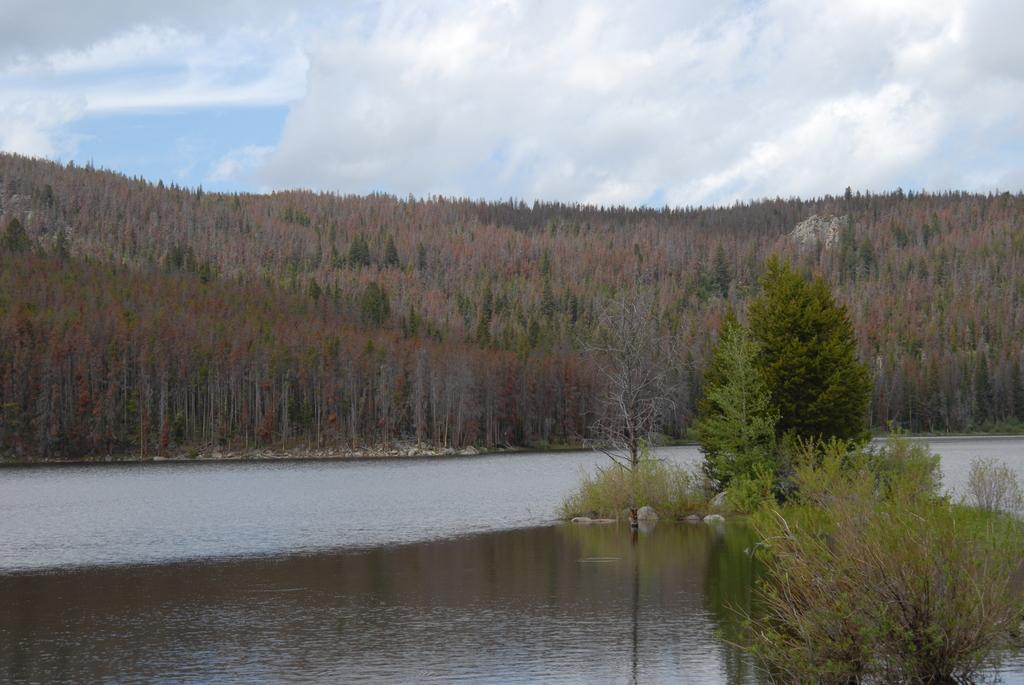In one or two sentences, can you explain what this image depicts? At the bottom of the image we can see water. In the middle of the image we can see some trees. At the top of the image we can see some clouds in the sky. 